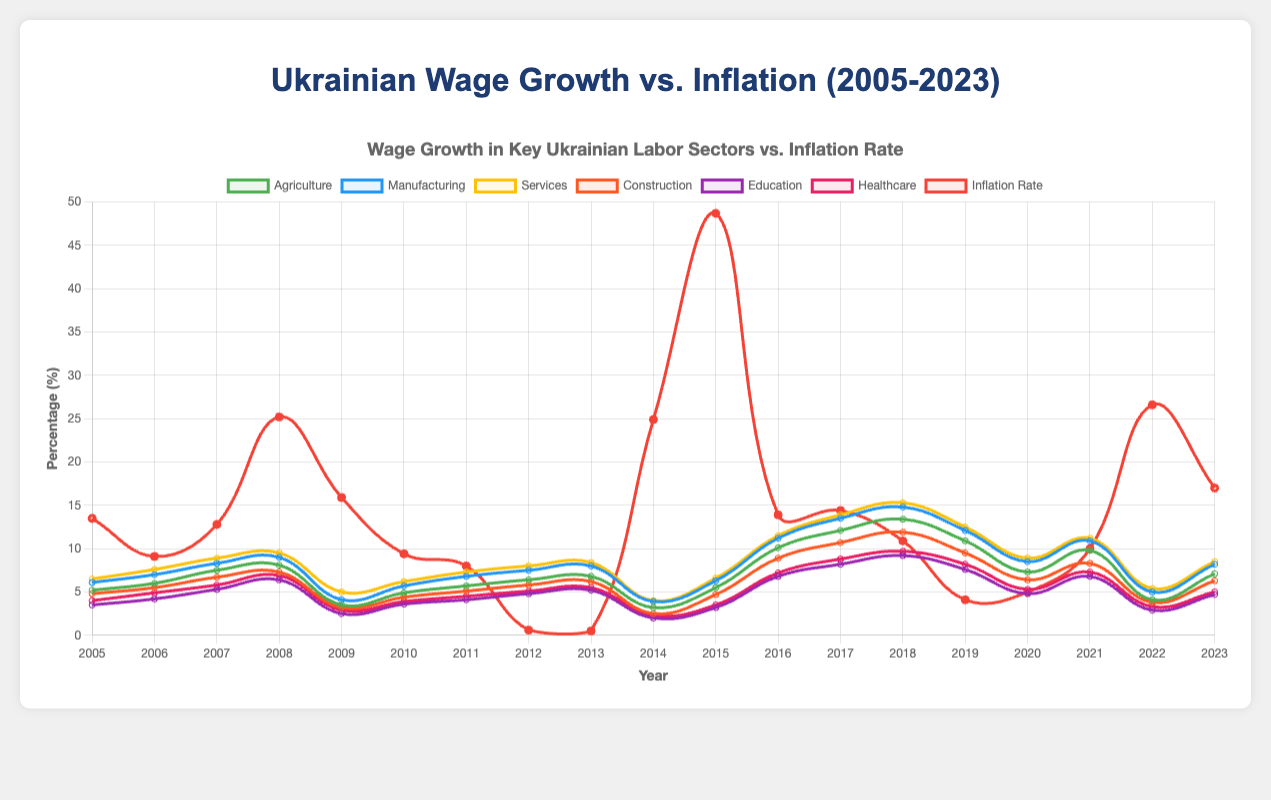What year had the maximum inflation rate, and what was the rate? Look at the inflation rate line on the graph and determine the highest peak. In 2015, the inflation rate reached its maximum at 48.7%.
Answer: 2015, 48.7% During which years did agriculture wage growth exceed the inflation rate? Identify the years where the agriculture wage growth line is above the inflation rate line. These years are 2012, 2013, 2016, 2017, 2018, 2019, 2020, 2021.
Answer: 2012, 2013, 2016, 2017, 2018, 2019, 2020, 2021 Which sector had the highest wage growth in 2009 and by how much? Compare the wage growth lines for all sectors in 2009. Services had the highest wage growth at 5.0%.
Answer: Services, 5.0% What is the average wage growth for the healthcare sector from 2010 to 2013? Sum the healthcare wage growth values from 2010 to 2013 and divide by the number of years: (3.9% + 4.5% + 5.1% + 5.5%) / 4 = 4.75%.
Answer: 4.75% In which year did the construction sector have the lowest wage growth, and what was the rate? Scan the construction sector line to identify its lowest point. The lowest wage growth occurred in 2014 at 2.5%.
Answer: 2014, 2.5% Compare the wage growth in the services sector with the inflation rate in 2020. Which one was higher? Look at the values for the services wage growth and inflation rate in 2020. The services sector had a wage growth of 8.9%, while the inflation rate was 5.0%. Thus, services wage growth was higher.
Answer: Services wage growth What was the difference between agriculture wage growth and inflation rate in 2009? Subtract the agriculture wage growth from the inflation rate in 2009: 15.9% - 3.5% = 12.4%.
Answer: 12.4% Which year had the highest average wage growth across all sectors, and what was the average rate? Calculate the average wage growth for each year and compare: (2018: (13.4% + 14.8% + 15.3% + 11.9% + 9.2% + 9.7%) / 6 = 12.38%). 2018 had the highest average wage growth rate.
Answer: 2018, 12.38% What is the trend of inflation rate compared to the wage growth in the healthcare sector from 2014 to 2018? Identify and examine the lines for inflation rate and healthcare wage growth from 2014 to 2018. The inflation rate saw a peak in 2015 (48.7%) but then declined. In contrast, healthcare wage growth consistently increased during this period.
Answer: Inflation rate declined overall, healthcare wage growth increased In which year did the wage growth in the manufacturing sector first exceed 10%, and what was the rate then? Scan the manufacturing sector line to find the earliest year where it exceeds 10%. The first year was 2016 with a rate of 11.2%.
Answer: 2016, 11.2% 